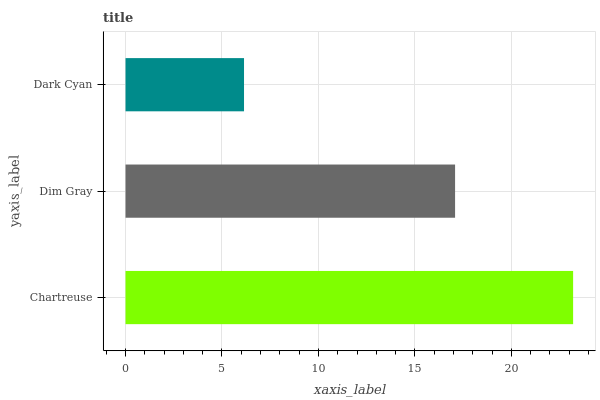Is Dark Cyan the minimum?
Answer yes or no. Yes. Is Chartreuse the maximum?
Answer yes or no. Yes. Is Dim Gray the minimum?
Answer yes or no. No. Is Dim Gray the maximum?
Answer yes or no. No. Is Chartreuse greater than Dim Gray?
Answer yes or no. Yes. Is Dim Gray less than Chartreuse?
Answer yes or no. Yes. Is Dim Gray greater than Chartreuse?
Answer yes or no. No. Is Chartreuse less than Dim Gray?
Answer yes or no. No. Is Dim Gray the high median?
Answer yes or no. Yes. Is Dim Gray the low median?
Answer yes or no. Yes. Is Chartreuse the high median?
Answer yes or no. No. Is Dark Cyan the low median?
Answer yes or no. No. 